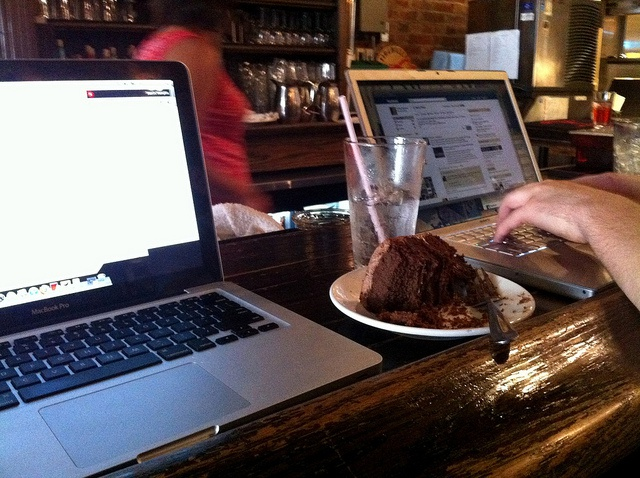Describe the objects in this image and their specific colors. I can see laptop in black, white, gray, and darkgray tones, laptop in black, gray, and maroon tones, people in black, maroon, and brown tones, people in black, lightpink, salmon, and maroon tones, and cup in black, gray, darkgray, and lavender tones in this image. 